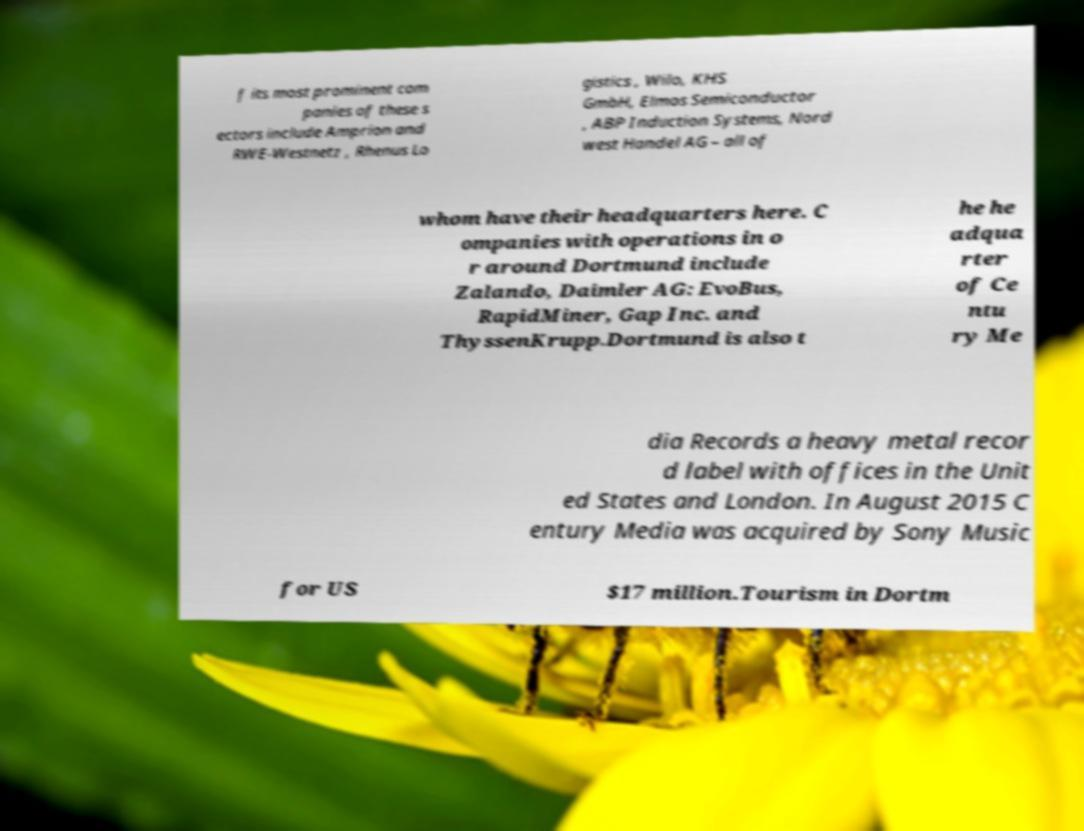What messages or text are displayed in this image? I need them in a readable, typed format. f its most prominent com panies of these s ectors include Amprion and RWE-Westnetz , Rhenus Lo gistics , Wilo, KHS GmbH, Elmos Semiconductor , ABP Induction Systems, Nord west Handel AG – all of whom have their headquarters here. C ompanies with operations in o r around Dortmund include Zalando, Daimler AG: EvoBus, RapidMiner, Gap Inc. and ThyssenKrupp.Dortmund is also t he he adqua rter of Ce ntu ry Me dia Records a heavy metal recor d label with offices in the Unit ed States and London. In August 2015 C entury Media was acquired by Sony Music for US $17 million.Tourism in Dortm 